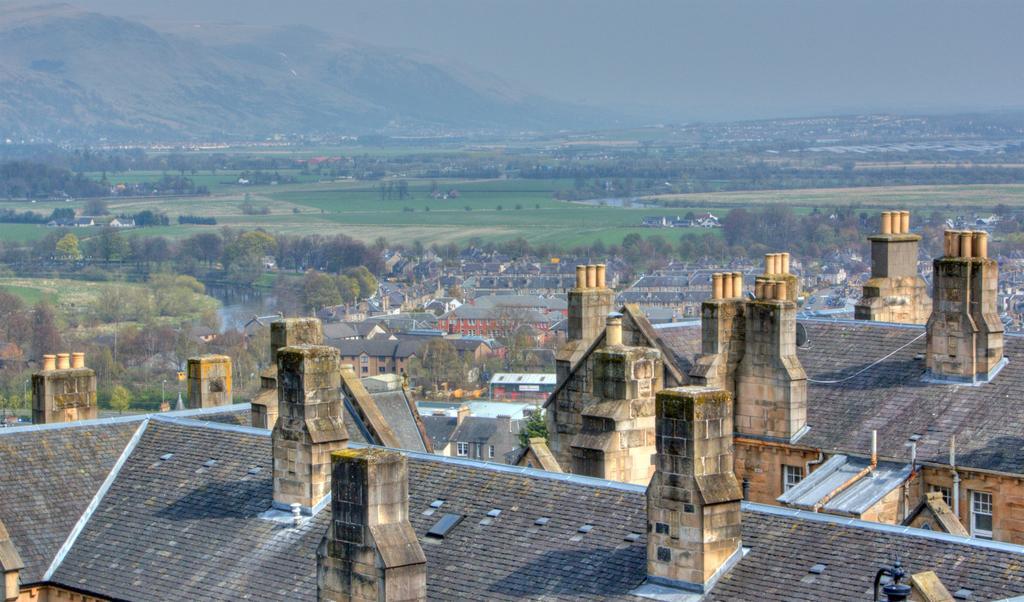How would you summarize this image in a sentence or two? In this image we can see buildings, trees, water, mountains and sky. 